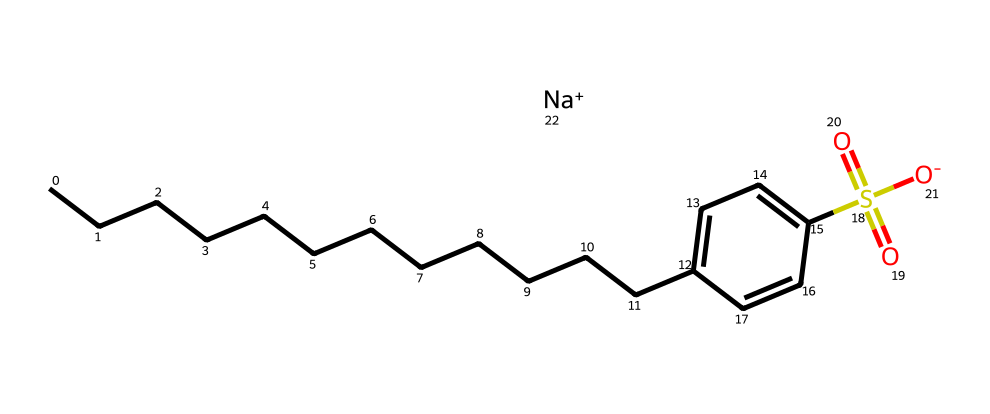What is the main functional group present in this chemical? The presence of the sulfonate group (S(=O)(=O)[O-]) indicates that the main functional group is sulfonate.
Answer: sulfonate How many carbon atoms are in the alkyl chain of this molecule? The alkyl chain is represented by the sequence of "C" atoms before the aromatic ring in the SMILES, which shows that there are 15 carbon atoms in total (13 in the chain and 2 in the aromatic component).
Answer: 15 What is the charge on the molecule at physiological pH? The molecule has a sodium cation ([Na+]) that balances the negative charge from the sulfonate group, presenting an overall neutral charge in solution.
Answer: neutral What distinguishes this surfactant as biodegradable? The linear alkylbenzene structure allows microbes to easily degrade it by utilizing the linear alkyl chain as a source of carbon, making it biodegradable.
Answer: structure Which type of surfactant is this chemical classified as? Given the negatively charged sulfonate group, this chemical is classified as an anionic surfactant, which is typical for laundry detergents.
Answer: anionic 